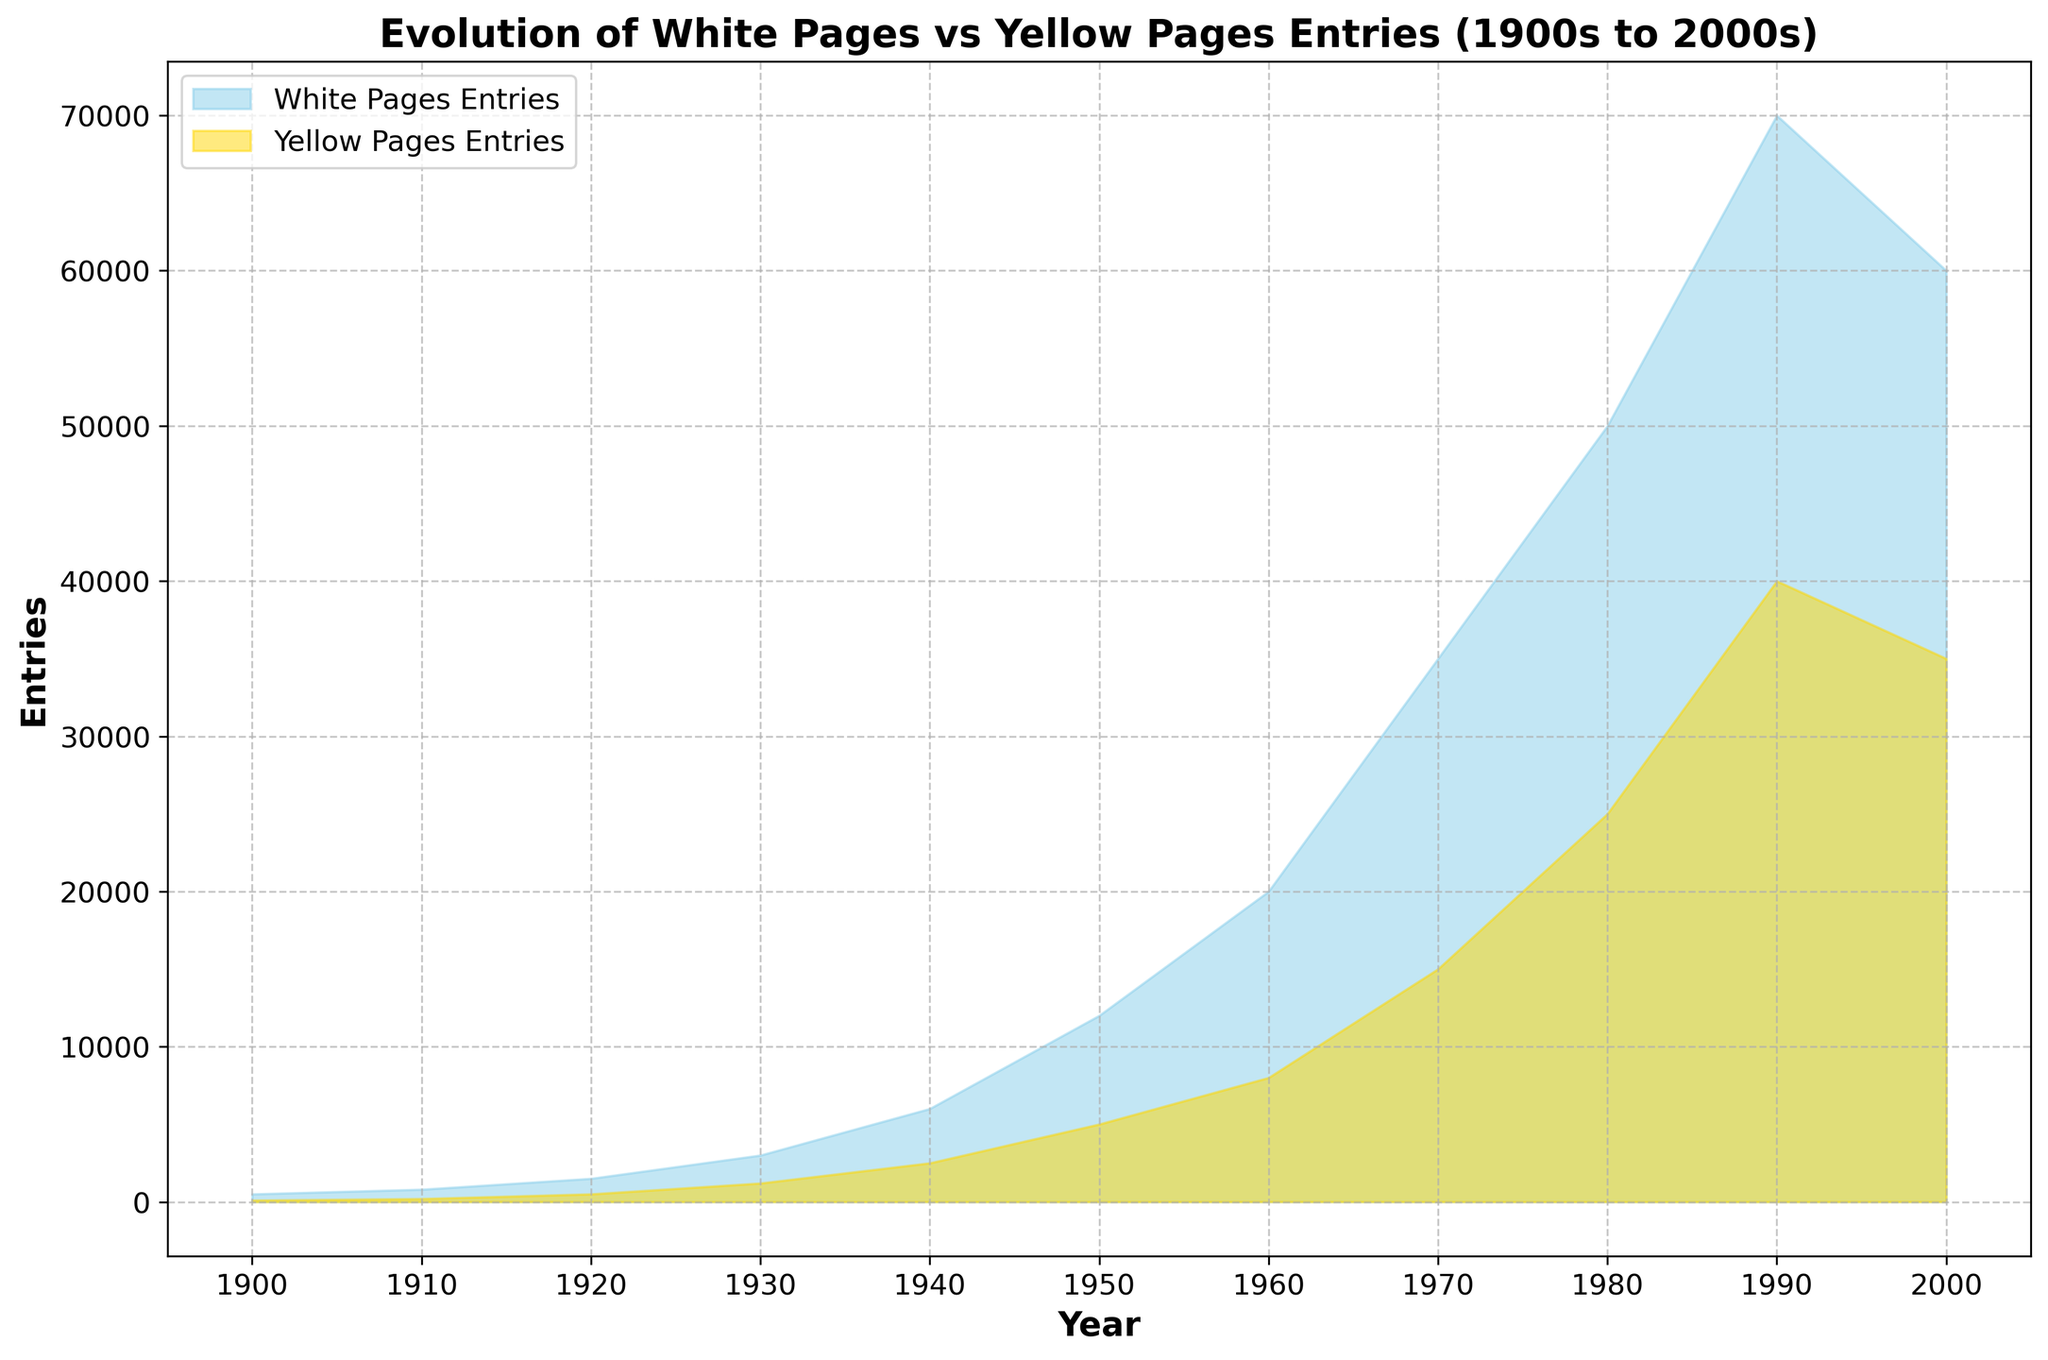How many more White Pages entries were there than Yellow Pages entries in 2000? In 2000, the White Pages had 60,000 entries, and the Yellow Pages had 35,000 entries. The difference is 60,000 - 35,000 = 25,000.
Answer: 25,000 Which year saw the largest number of Yellow Pages entries? The year with the highest peak in Yellow Pages entries on the area chart is 1990, with 40,000 entries.
Answer: 1990 Between which years did the White Pages entries experience the most significant growth? By examining the area chart, the steepest increase for White Pages entries occurs between 1940 and 1970. The growth from 6,000 in 1940 to 35,000 in 1970 = 29,000 entries.
Answer: 1940 to 1970 During which decade did both White Pages and Yellow Pages entries double roughly from their previous decade? From 1930 to 1940, White Pages entries increased from 3,000 to 6,000 and Yellow Pages entries from 1,200 to 2,500, which is a doubling.
Answer: 1930 to 1940 What is the total number of entries (White and Yellow Pages) in 1950? Sum of White Pages and Yellow Pages entries in 1950: 12,000 (White) + 5,000 (Yellow) = 17,000.
Answer: 17,000 In which decade did Yellow Pages entries grow at the fastest rate? The most significant growth rate for Yellow Pages entries occurs between 1970 and 1980, increasing from 15,000 to 25,000, which is an increment of 10,000.
Answer: 1970 to 1980 Describe the patterns observed in the White Pages entries from 1900 to 2000 based on the chart. From the chart, White Pages entries show a steady increase from 500 in 1900 to 70,000 in 1990, followed by a decline to 60,000 by 2000.
Answer: Steady increase followed by a decline What is the ratio of White Pages entries to Yellow Pages entries in 1980? In 1980, White Pages entries are 50,000 and Yellow Pages entries are 25,000. The ratio is 50,000:25,000 = 2:1.
Answer: 2:1 Which color represents White Pages entries and which represents Yellow Pages entries in the chart? According to the legend in the chart, White Pages entries are represented in sky blue, and Yellow Pages entries are represented in gold.
Answer: Sky blue (White Pages), Gold (Yellow Pages) What can be inferred about the trends of White Pages and Yellow Pages entries after 1990? The White Pages entries begin to decline after 1990 from 70,000 to 60,000 in 2000, while Yellow Pages entries also show a slight decrease from 40,000 to 35,000 in 2000.
Answer: Decline for both 